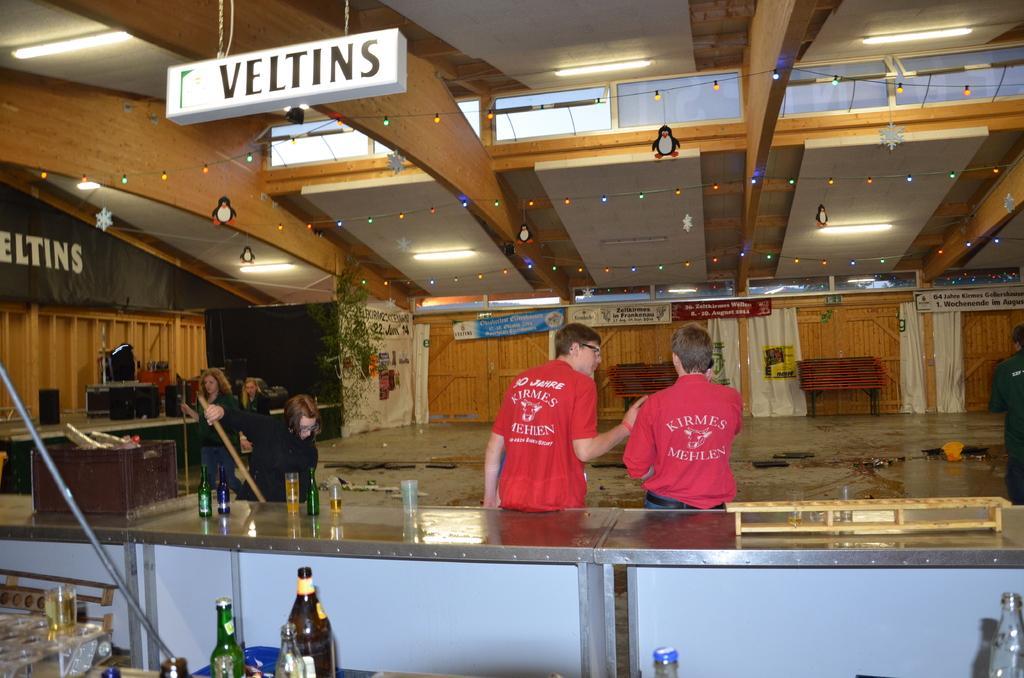In one or two sentences, can you explain what this image depicts? This image seems to be clicked inside bar, there are beer bottles,glasses in the front on the table with two men in red t-shirt standing in front of it, on the right side there are three women sweeping the floor, over the ceiling there are lights, in the back there are doors on the wall. 